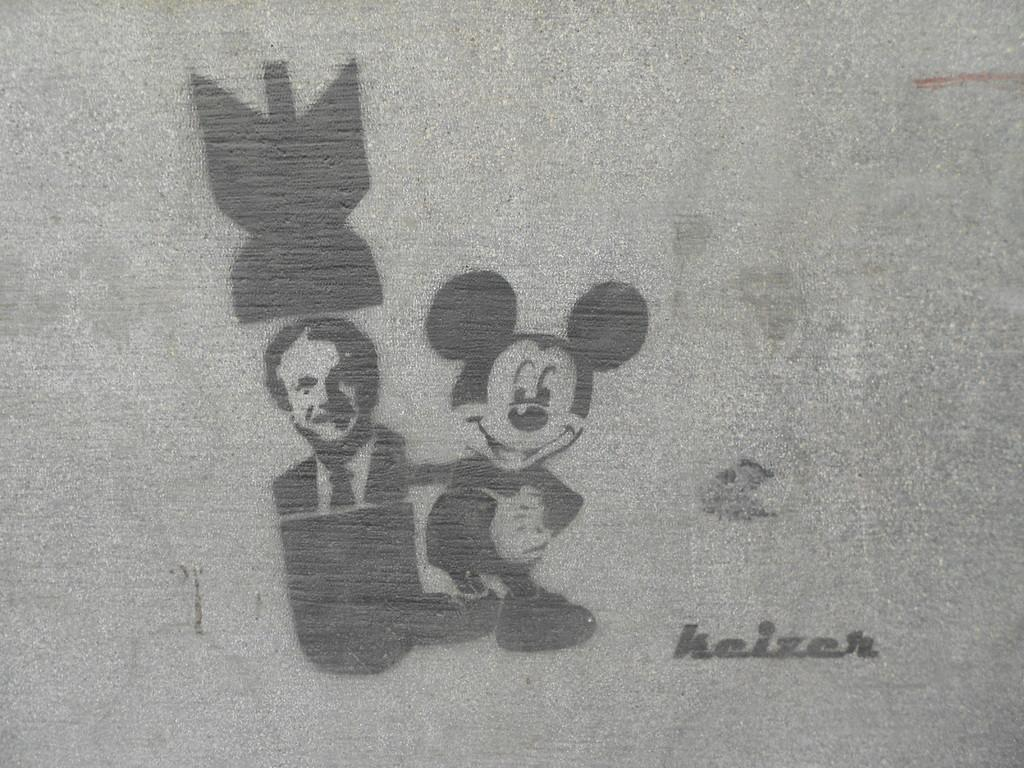What type of object is featured in the image? The image contains an art piece. What is depicted in the art piece? The art piece includes a person and Mickey Mouse. Where is the friend of the person in the art piece sleeping in the image? There is no friend or bedroom present in the image; it only features a person and Mickey Mouse in an art piece. What type of vessel is being used by the person in the art piece? There is no vessel present in the image; it only features a person and Mickey Mouse in an art piece. 